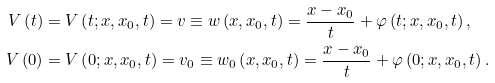<formula> <loc_0><loc_0><loc_500><loc_500>V \left ( t \right ) & = V \left ( t ; x , x _ { 0 } , t \right ) = v \equiv w \left ( x , x _ { 0 } , t \right ) = \frac { x - x _ { 0 } } { t } + \varphi \left ( t ; x , x _ { 0 } , t \right ) , \\ V \left ( 0 \right ) & = V \left ( 0 ; x , x _ { 0 } , t \right ) = v _ { 0 } \equiv w _ { 0 } \left ( x , x _ { 0 } , t \right ) = \frac { x - x _ { 0 } } { t } + \varphi \left ( 0 ; x , x _ { 0 } , t \right ) .</formula> 